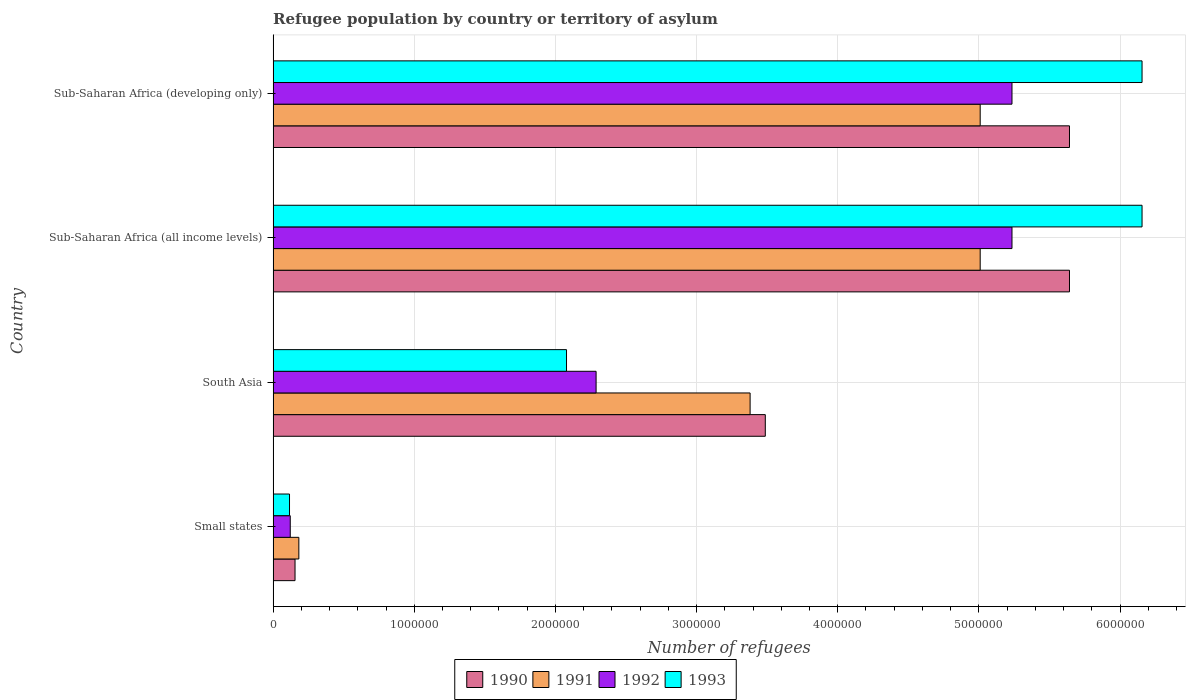How many groups of bars are there?
Give a very brief answer. 4. How many bars are there on the 3rd tick from the top?
Provide a succinct answer. 4. What is the label of the 2nd group of bars from the top?
Offer a very short reply. Sub-Saharan Africa (all income levels). In how many cases, is the number of bars for a given country not equal to the number of legend labels?
Your response must be concise. 0. What is the number of refugees in 1990 in Small states?
Provide a short and direct response. 1.55e+05. Across all countries, what is the maximum number of refugees in 1993?
Your answer should be very brief. 6.16e+06. Across all countries, what is the minimum number of refugees in 1992?
Your answer should be compact. 1.21e+05. In which country was the number of refugees in 1993 maximum?
Your response must be concise. Sub-Saharan Africa (all income levels). In which country was the number of refugees in 1992 minimum?
Your response must be concise. Small states. What is the total number of refugees in 1990 in the graph?
Your answer should be compact. 1.49e+07. What is the difference between the number of refugees in 1993 in South Asia and that in Sub-Saharan Africa (all income levels)?
Your answer should be very brief. -4.08e+06. What is the difference between the number of refugees in 1990 in Sub-Saharan Africa (developing only) and the number of refugees in 1993 in Small states?
Provide a short and direct response. 5.53e+06. What is the average number of refugees in 1993 per country?
Keep it short and to the point. 3.63e+06. What is the difference between the number of refugees in 1991 and number of refugees in 1993 in Sub-Saharan Africa (developing only)?
Provide a short and direct response. -1.15e+06. In how many countries, is the number of refugees in 1992 greater than 3400000 ?
Your answer should be very brief. 2. Is the difference between the number of refugees in 1991 in Small states and Sub-Saharan Africa (developing only) greater than the difference between the number of refugees in 1993 in Small states and Sub-Saharan Africa (developing only)?
Offer a very short reply. Yes. What is the difference between the highest and the lowest number of refugees in 1990?
Provide a succinct answer. 5.49e+06. What does the 4th bar from the top in Sub-Saharan Africa (developing only) represents?
Give a very brief answer. 1990. Is it the case that in every country, the sum of the number of refugees in 1991 and number of refugees in 1993 is greater than the number of refugees in 1990?
Provide a short and direct response. Yes. Are all the bars in the graph horizontal?
Your answer should be very brief. Yes. What is the difference between two consecutive major ticks on the X-axis?
Your response must be concise. 1.00e+06. Where does the legend appear in the graph?
Your answer should be compact. Bottom center. How many legend labels are there?
Your answer should be compact. 4. What is the title of the graph?
Offer a terse response. Refugee population by country or territory of asylum. What is the label or title of the X-axis?
Your answer should be compact. Number of refugees. What is the label or title of the Y-axis?
Your response must be concise. Country. What is the Number of refugees of 1990 in Small states?
Your response must be concise. 1.55e+05. What is the Number of refugees of 1991 in Small states?
Provide a short and direct response. 1.82e+05. What is the Number of refugees in 1992 in Small states?
Provide a short and direct response. 1.21e+05. What is the Number of refugees of 1993 in Small states?
Offer a very short reply. 1.16e+05. What is the Number of refugees of 1990 in South Asia?
Your answer should be compact. 3.49e+06. What is the Number of refugees of 1991 in South Asia?
Provide a short and direct response. 3.38e+06. What is the Number of refugees of 1992 in South Asia?
Offer a terse response. 2.29e+06. What is the Number of refugees of 1993 in South Asia?
Make the answer very short. 2.08e+06. What is the Number of refugees of 1990 in Sub-Saharan Africa (all income levels)?
Offer a very short reply. 5.64e+06. What is the Number of refugees of 1991 in Sub-Saharan Africa (all income levels)?
Your response must be concise. 5.01e+06. What is the Number of refugees of 1992 in Sub-Saharan Africa (all income levels)?
Provide a short and direct response. 5.23e+06. What is the Number of refugees of 1993 in Sub-Saharan Africa (all income levels)?
Your answer should be very brief. 6.16e+06. What is the Number of refugees of 1990 in Sub-Saharan Africa (developing only)?
Your answer should be compact. 5.64e+06. What is the Number of refugees of 1991 in Sub-Saharan Africa (developing only)?
Your response must be concise. 5.01e+06. What is the Number of refugees in 1992 in Sub-Saharan Africa (developing only)?
Keep it short and to the point. 5.23e+06. What is the Number of refugees in 1993 in Sub-Saharan Africa (developing only)?
Your response must be concise. 6.16e+06. Across all countries, what is the maximum Number of refugees in 1990?
Provide a succinct answer. 5.64e+06. Across all countries, what is the maximum Number of refugees of 1991?
Offer a very short reply. 5.01e+06. Across all countries, what is the maximum Number of refugees in 1992?
Provide a succinct answer. 5.23e+06. Across all countries, what is the maximum Number of refugees in 1993?
Keep it short and to the point. 6.16e+06. Across all countries, what is the minimum Number of refugees of 1990?
Keep it short and to the point. 1.55e+05. Across all countries, what is the minimum Number of refugees in 1991?
Provide a short and direct response. 1.82e+05. Across all countries, what is the minimum Number of refugees in 1992?
Ensure brevity in your answer.  1.21e+05. Across all countries, what is the minimum Number of refugees in 1993?
Your response must be concise. 1.16e+05. What is the total Number of refugees in 1990 in the graph?
Offer a very short reply. 1.49e+07. What is the total Number of refugees of 1991 in the graph?
Your answer should be compact. 1.36e+07. What is the total Number of refugees of 1992 in the graph?
Keep it short and to the point. 1.29e+07. What is the total Number of refugees in 1993 in the graph?
Your answer should be compact. 1.45e+07. What is the difference between the Number of refugees in 1990 in Small states and that in South Asia?
Ensure brevity in your answer.  -3.33e+06. What is the difference between the Number of refugees of 1991 in Small states and that in South Asia?
Keep it short and to the point. -3.20e+06. What is the difference between the Number of refugees of 1992 in Small states and that in South Asia?
Keep it short and to the point. -2.17e+06. What is the difference between the Number of refugees in 1993 in Small states and that in South Asia?
Ensure brevity in your answer.  -1.96e+06. What is the difference between the Number of refugees in 1990 in Small states and that in Sub-Saharan Africa (all income levels)?
Give a very brief answer. -5.49e+06. What is the difference between the Number of refugees of 1991 in Small states and that in Sub-Saharan Africa (all income levels)?
Offer a terse response. -4.83e+06. What is the difference between the Number of refugees in 1992 in Small states and that in Sub-Saharan Africa (all income levels)?
Your answer should be compact. -5.11e+06. What is the difference between the Number of refugees in 1993 in Small states and that in Sub-Saharan Africa (all income levels)?
Your response must be concise. -6.04e+06. What is the difference between the Number of refugees of 1990 in Small states and that in Sub-Saharan Africa (developing only)?
Your answer should be compact. -5.49e+06. What is the difference between the Number of refugees of 1991 in Small states and that in Sub-Saharan Africa (developing only)?
Provide a succinct answer. -4.83e+06. What is the difference between the Number of refugees of 1992 in Small states and that in Sub-Saharan Africa (developing only)?
Offer a very short reply. -5.11e+06. What is the difference between the Number of refugees in 1993 in Small states and that in Sub-Saharan Africa (developing only)?
Offer a very short reply. -6.04e+06. What is the difference between the Number of refugees of 1990 in South Asia and that in Sub-Saharan Africa (all income levels)?
Make the answer very short. -2.15e+06. What is the difference between the Number of refugees in 1991 in South Asia and that in Sub-Saharan Africa (all income levels)?
Make the answer very short. -1.63e+06. What is the difference between the Number of refugees in 1992 in South Asia and that in Sub-Saharan Africa (all income levels)?
Your response must be concise. -2.95e+06. What is the difference between the Number of refugees in 1993 in South Asia and that in Sub-Saharan Africa (all income levels)?
Offer a very short reply. -4.08e+06. What is the difference between the Number of refugees in 1990 in South Asia and that in Sub-Saharan Africa (developing only)?
Give a very brief answer. -2.15e+06. What is the difference between the Number of refugees of 1991 in South Asia and that in Sub-Saharan Africa (developing only)?
Offer a terse response. -1.63e+06. What is the difference between the Number of refugees of 1992 in South Asia and that in Sub-Saharan Africa (developing only)?
Offer a very short reply. -2.95e+06. What is the difference between the Number of refugees in 1993 in South Asia and that in Sub-Saharan Africa (developing only)?
Your response must be concise. -4.08e+06. What is the difference between the Number of refugees in 1990 in Sub-Saharan Africa (all income levels) and that in Sub-Saharan Africa (developing only)?
Your response must be concise. 0. What is the difference between the Number of refugees in 1991 in Sub-Saharan Africa (all income levels) and that in Sub-Saharan Africa (developing only)?
Keep it short and to the point. 0. What is the difference between the Number of refugees of 1992 in Sub-Saharan Africa (all income levels) and that in Sub-Saharan Africa (developing only)?
Keep it short and to the point. 0. What is the difference between the Number of refugees of 1993 in Sub-Saharan Africa (all income levels) and that in Sub-Saharan Africa (developing only)?
Keep it short and to the point. 0. What is the difference between the Number of refugees in 1990 in Small states and the Number of refugees in 1991 in South Asia?
Ensure brevity in your answer.  -3.22e+06. What is the difference between the Number of refugees of 1990 in Small states and the Number of refugees of 1992 in South Asia?
Ensure brevity in your answer.  -2.13e+06. What is the difference between the Number of refugees of 1990 in Small states and the Number of refugees of 1993 in South Asia?
Your response must be concise. -1.92e+06. What is the difference between the Number of refugees in 1991 in Small states and the Number of refugees in 1992 in South Asia?
Provide a short and direct response. -2.11e+06. What is the difference between the Number of refugees of 1991 in Small states and the Number of refugees of 1993 in South Asia?
Your answer should be compact. -1.90e+06. What is the difference between the Number of refugees in 1992 in Small states and the Number of refugees in 1993 in South Asia?
Offer a terse response. -1.96e+06. What is the difference between the Number of refugees in 1990 in Small states and the Number of refugees in 1991 in Sub-Saharan Africa (all income levels)?
Provide a succinct answer. -4.85e+06. What is the difference between the Number of refugees of 1990 in Small states and the Number of refugees of 1992 in Sub-Saharan Africa (all income levels)?
Offer a terse response. -5.08e+06. What is the difference between the Number of refugees of 1990 in Small states and the Number of refugees of 1993 in Sub-Saharan Africa (all income levels)?
Your response must be concise. -6.00e+06. What is the difference between the Number of refugees of 1991 in Small states and the Number of refugees of 1992 in Sub-Saharan Africa (all income levels)?
Offer a very short reply. -5.05e+06. What is the difference between the Number of refugees of 1991 in Small states and the Number of refugees of 1993 in Sub-Saharan Africa (all income levels)?
Provide a short and direct response. -5.97e+06. What is the difference between the Number of refugees in 1992 in Small states and the Number of refugees in 1993 in Sub-Saharan Africa (all income levels)?
Your response must be concise. -6.03e+06. What is the difference between the Number of refugees in 1990 in Small states and the Number of refugees in 1991 in Sub-Saharan Africa (developing only)?
Offer a terse response. -4.85e+06. What is the difference between the Number of refugees in 1990 in Small states and the Number of refugees in 1992 in Sub-Saharan Africa (developing only)?
Your answer should be compact. -5.08e+06. What is the difference between the Number of refugees of 1990 in Small states and the Number of refugees of 1993 in Sub-Saharan Africa (developing only)?
Give a very brief answer. -6.00e+06. What is the difference between the Number of refugees of 1991 in Small states and the Number of refugees of 1992 in Sub-Saharan Africa (developing only)?
Give a very brief answer. -5.05e+06. What is the difference between the Number of refugees in 1991 in Small states and the Number of refugees in 1993 in Sub-Saharan Africa (developing only)?
Offer a terse response. -5.97e+06. What is the difference between the Number of refugees of 1992 in Small states and the Number of refugees of 1993 in Sub-Saharan Africa (developing only)?
Your answer should be very brief. -6.03e+06. What is the difference between the Number of refugees in 1990 in South Asia and the Number of refugees in 1991 in Sub-Saharan Africa (all income levels)?
Your response must be concise. -1.52e+06. What is the difference between the Number of refugees in 1990 in South Asia and the Number of refugees in 1992 in Sub-Saharan Africa (all income levels)?
Keep it short and to the point. -1.75e+06. What is the difference between the Number of refugees of 1990 in South Asia and the Number of refugees of 1993 in Sub-Saharan Africa (all income levels)?
Your answer should be very brief. -2.67e+06. What is the difference between the Number of refugees of 1991 in South Asia and the Number of refugees of 1992 in Sub-Saharan Africa (all income levels)?
Ensure brevity in your answer.  -1.86e+06. What is the difference between the Number of refugees of 1991 in South Asia and the Number of refugees of 1993 in Sub-Saharan Africa (all income levels)?
Offer a terse response. -2.78e+06. What is the difference between the Number of refugees of 1992 in South Asia and the Number of refugees of 1993 in Sub-Saharan Africa (all income levels)?
Your answer should be compact. -3.87e+06. What is the difference between the Number of refugees in 1990 in South Asia and the Number of refugees in 1991 in Sub-Saharan Africa (developing only)?
Your answer should be very brief. -1.52e+06. What is the difference between the Number of refugees of 1990 in South Asia and the Number of refugees of 1992 in Sub-Saharan Africa (developing only)?
Your answer should be very brief. -1.75e+06. What is the difference between the Number of refugees of 1990 in South Asia and the Number of refugees of 1993 in Sub-Saharan Africa (developing only)?
Ensure brevity in your answer.  -2.67e+06. What is the difference between the Number of refugees of 1991 in South Asia and the Number of refugees of 1992 in Sub-Saharan Africa (developing only)?
Make the answer very short. -1.86e+06. What is the difference between the Number of refugees in 1991 in South Asia and the Number of refugees in 1993 in Sub-Saharan Africa (developing only)?
Offer a very short reply. -2.78e+06. What is the difference between the Number of refugees in 1992 in South Asia and the Number of refugees in 1993 in Sub-Saharan Africa (developing only)?
Ensure brevity in your answer.  -3.87e+06. What is the difference between the Number of refugees of 1990 in Sub-Saharan Africa (all income levels) and the Number of refugees of 1991 in Sub-Saharan Africa (developing only)?
Make the answer very short. 6.33e+05. What is the difference between the Number of refugees in 1990 in Sub-Saharan Africa (all income levels) and the Number of refugees in 1992 in Sub-Saharan Africa (developing only)?
Your response must be concise. 4.07e+05. What is the difference between the Number of refugees in 1990 in Sub-Saharan Africa (all income levels) and the Number of refugees in 1993 in Sub-Saharan Africa (developing only)?
Keep it short and to the point. -5.14e+05. What is the difference between the Number of refugees in 1991 in Sub-Saharan Africa (all income levels) and the Number of refugees in 1992 in Sub-Saharan Africa (developing only)?
Keep it short and to the point. -2.25e+05. What is the difference between the Number of refugees in 1991 in Sub-Saharan Africa (all income levels) and the Number of refugees in 1993 in Sub-Saharan Africa (developing only)?
Give a very brief answer. -1.15e+06. What is the difference between the Number of refugees in 1992 in Sub-Saharan Africa (all income levels) and the Number of refugees in 1993 in Sub-Saharan Africa (developing only)?
Keep it short and to the point. -9.21e+05. What is the average Number of refugees of 1990 per country?
Give a very brief answer. 3.73e+06. What is the average Number of refugees of 1991 per country?
Keep it short and to the point. 3.39e+06. What is the average Number of refugees of 1992 per country?
Offer a very short reply. 3.22e+06. What is the average Number of refugees in 1993 per country?
Provide a succinct answer. 3.63e+06. What is the difference between the Number of refugees of 1990 and Number of refugees of 1991 in Small states?
Your answer should be compact. -2.70e+04. What is the difference between the Number of refugees in 1990 and Number of refugees in 1992 in Small states?
Your answer should be very brief. 3.39e+04. What is the difference between the Number of refugees in 1990 and Number of refugees in 1993 in Small states?
Your answer should be very brief. 3.91e+04. What is the difference between the Number of refugees of 1991 and Number of refugees of 1992 in Small states?
Offer a terse response. 6.09e+04. What is the difference between the Number of refugees in 1991 and Number of refugees in 1993 in Small states?
Keep it short and to the point. 6.61e+04. What is the difference between the Number of refugees of 1992 and Number of refugees of 1993 in Small states?
Your answer should be very brief. 5179. What is the difference between the Number of refugees in 1990 and Number of refugees in 1991 in South Asia?
Provide a short and direct response. 1.08e+05. What is the difference between the Number of refugees of 1990 and Number of refugees of 1992 in South Asia?
Make the answer very short. 1.20e+06. What is the difference between the Number of refugees in 1990 and Number of refugees in 1993 in South Asia?
Provide a short and direct response. 1.41e+06. What is the difference between the Number of refugees in 1991 and Number of refugees in 1992 in South Asia?
Your answer should be compact. 1.09e+06. What is the difference between the Number of refugees of 1991 and Number of refugees of 1993 in South Asia?
Your answer should be compact. 1.30e+06. What is the difference between the Number of refugees in 1992 and Number of refugees in 1993 in South Asia?
Ensure brevity in your answer.  2.10e+05. What is the difference between the Number of refugees of 1990 and Number of refugees of 1991 in Sub-Saharan Africa (all income levels)?
Ensure brevity in your answer.  6.33e+05. What is the difference between the Number of refugees in 1990 and Number of refugees in 1992 in Sub-Saharan Africa (all income levels)?
Your response must be concise. 4.07e+05. What is the difference between the Number of refugees in 1990 and Number of refugees in 1993 in Sub-Saharan Africa (all income levels)?
Your response must be concise. -5.14e+05. What is the difference between the Number of refugees in 1991 and Number of refugees in 1992 in Sub-Saharan Africa (all income levels)?
Your response must be concise. -2.25e+05. What is the difference between the Number of refugees in 1991 and Number of refugees in 1993 in Sub-Saharan Africa (all income levels)?
Your response must be concise. -1.15e+06. What is the difference between the Number of refugees of 1992 and Number of refugees of 1993 in Sub-Saharan Africa (all income levels)?
Keep it short and to the point. -9.21e+05. What is the difference between the Number of refugees in 1990 and Number of refugees in 1991 in Sub-Saharan Africa (developing only)?
Offer a terse response. 6.33e+05. What is the difference between the Number of refugees in 1990 and Number of refugees in 1992 in Sub-Saharan Africa (developing only)?
Provide a short and direct response. 4.07e+05. What is the difference between the Number of refugees of 1990 and Number of refugees of 1993 in Sub-Saharan Africa (developing only)?
Your response must be concise. -5.14e+05. What is the difference between the Number of refugees in 1991 and Number of refugees in 1992 in Sub-Saharan Africa (developing only)?
Your response must be concise. -2.25e+05. What is the difference between the Number of refugees of 1991 and Number of refugees of 1993 in Sub-Saharan Africa (developing only)?
Give a very brief answer. -1.15e+06. What is the difference between the Number of refugees of 1992 and Number of refugees of 1993 in Sub-Saharan Africa (developing only)?
Make the answer very short. -9.21e+05. What is the ratio of the Number of refugees in 1990 in Small states to that in South Asia?
Make the answer very short. 0.04. What is the ratio of the Number of refugees of 1991 in Small states to that in South Asia?
Give a very brief answer. 0.05. What is the ratio of the Number of refugees of 1992 in Small states to that in South Asia?
Provide a succinct answer. 0.05. What is the ratio of the Number of refugees in 1993 in Small states to that in South Asia?
Ensure brevity in your answer.  0.06. What is the ratio of the Number of refugees of 1990 in Small states to that in Sub-Saharan Africa (all income levels)?
Offer a terse response. 0.03. What is the ratio of the Number of refugees in 1991 in Small states to that in Sub-Saharan Africa (all income levels)?
Provide a short and direct response. 0.04. What is the ratio of the Number of refugees of 1992 in Small states to that in Sub-Saharan Africa (all income levels)?
Keep it short and to the point. 0.02. What is the ratio of the Number of refugees of 1993 in Small states to that in Sub-Saharan Africa (all income levels)?
Give a very brief answer. 0.02. What is the ratio of the Number of refugees of 1990 in Small states to that in Sub-Saharan Africa (developing only)?
Keep it short and to the point. 0.03. What is the ratio of the Number of refugees in 1991 in Small states to that in Sub-Saharan Africa (developing only)?
Provide a succinct answer. 0.04. What is the ratio of the Number of refugees of 1992 in Small states to that in Sub-Saharan Africa (developing only)?
Keep it short and to the point. 0.02. What is the ratio of the Number of refugees of 1993 in Small states to that in Sub-Saharan Africa (developing only)?
Provide a succinct answer. 0.02. What is the ratio of the Number of refugees in 1990 in South Asia to that in Sub-Saharan Africa (all income levels)?
Your answer should be compact. 0.62. What is the ratio of the Number of refugees in 1991 in South Asia to that in Sub-Saharan Africa (all income levels)?
Offer a very short reply. 0.67. What is the ratio of the Number of refugees of 1992 in South Asia to that in Sub-Saharan Africa (all income levels)?
Provide a short and direct response. 0.44. What is the ratio of the Number of refugees in 1993 in South Asia to that in Sub-Saharan Africa (all income levels)?
Ensure brevity in your answer.  0.34. What is the ratio of the Number of refugees of 1990 in South Asia to that in Sub-Saharan Africa (developing only)?
Provide a short and direct response. 0.62. What is the ratio of the Number of refugees in 1991 in South Asia to that in Sub-Saharan Africa (developing only)?
Your response must be concise. 0.67. What is the ratio of the Number of refugees in 1992 in South Asia to that in Sub-Saharan Africa (developing only)?
Provide a succinct answer. 0.44. What is the ratio of the Number of refugees in 1993 in South Asia to that in Sub-Saharan Africa (developing only)?
Provide a succinct answer. 0.34. What is the ratio of the Number of refugees in 1990 in Sub-Saharan Africa (all income levels) to that in Sub-Saharan Africa (developing only)?
Give a very brief answer. 1. What is the ratio of the Number of refugees of 1993 in Sub-Saharan Africa (all income levels) to that in Sub-Saharan Africa (developing only)?
Your answer should be compact. 1. What is the difference between the highest and the second highest Number of refugees in 1990?
Your answer should be compact. 0. What is the difference between the highest and the second highest Number of refugees in 1992?
Ensure brevity in your answer.  0. What is the difference between the highest and the second highest Number of refugees in 1993?
Provide a short and direct response. 0. What is the difference between the highest and the lowest Number of refugees of 1990?
Provide a short and direct response. 5.49e+06. What is the difference between the highest and the lowest Number of refugees in 1991?
Your answer should be very brief. 4.83e+06. What is the difference between the highest and the lowest Number of refugees of 1992?
Keep it short and to the point. 5.11e+06. What is the difference between the highest and the lowest Number of refugees of 1993?
Offer a very short reply. 6.04e+06. 